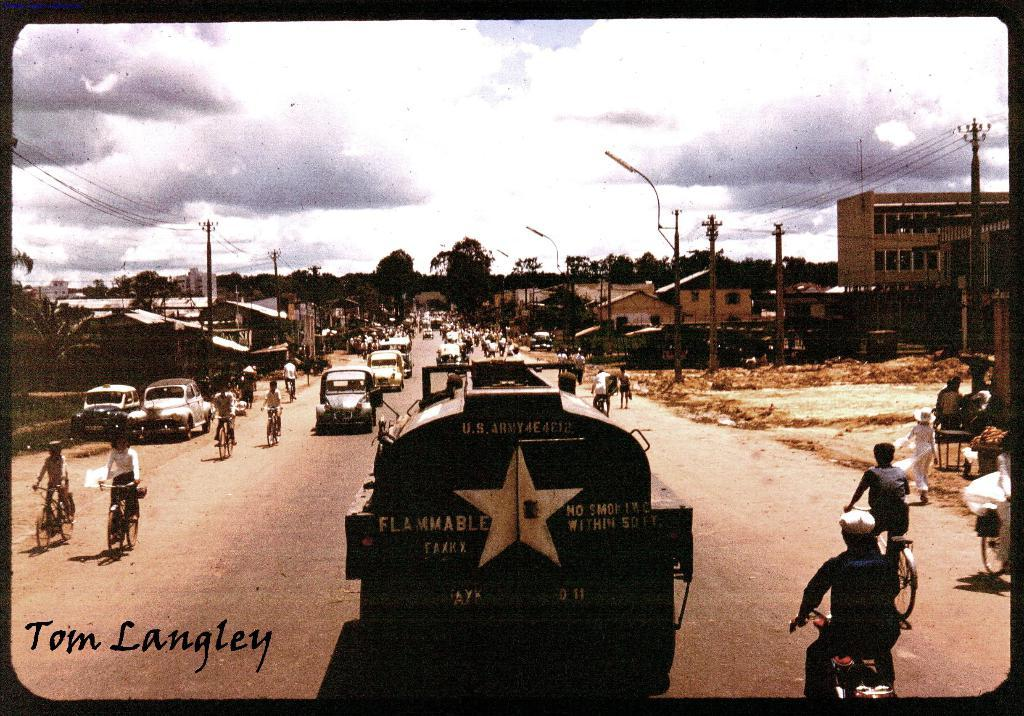<image>
Give a short and clear explanation of the subsequent image. Oil tanker truck that is passing through the streets that is flammable, it is taken by Tom Langley. 